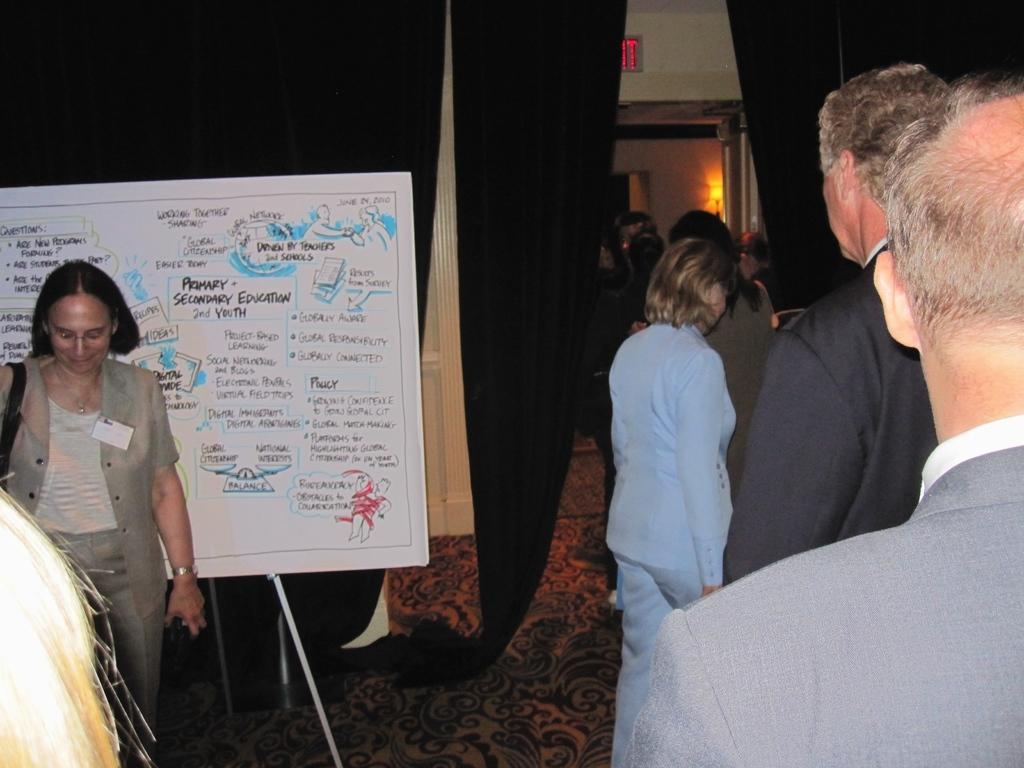Describe this image in one or two sentences. In this image I can see a group of people are standing on the floor, board, stand, curtains, wall, door and lights. This image is taken may be in a hall. 